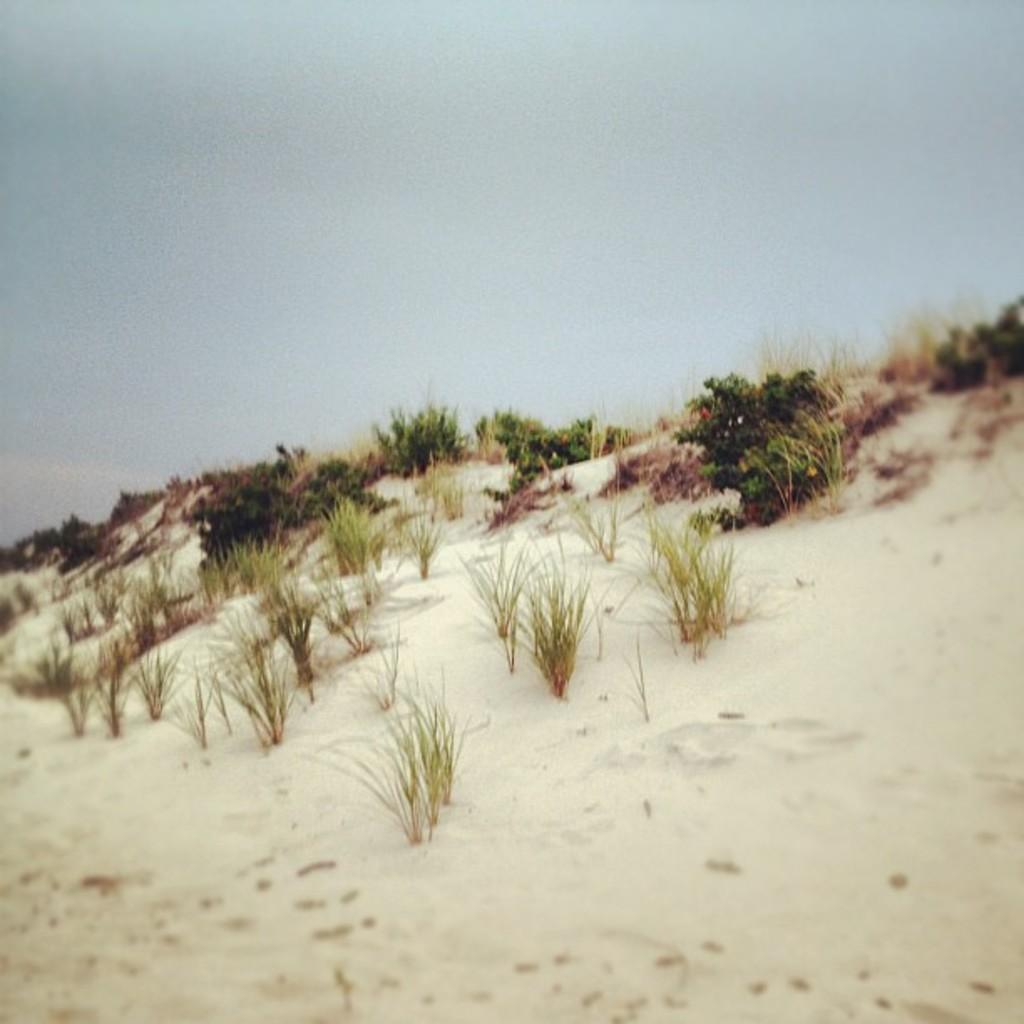What type of vegetation is present on the ground in the image? There are plants on the ground in the image. What can be seen in the background of the image? The sky is visible in the background of the image. What type of learning is taking place in the image? There is no indication of any learning taking place in the image; it primarily features plants on the ground and the sky in the background. 